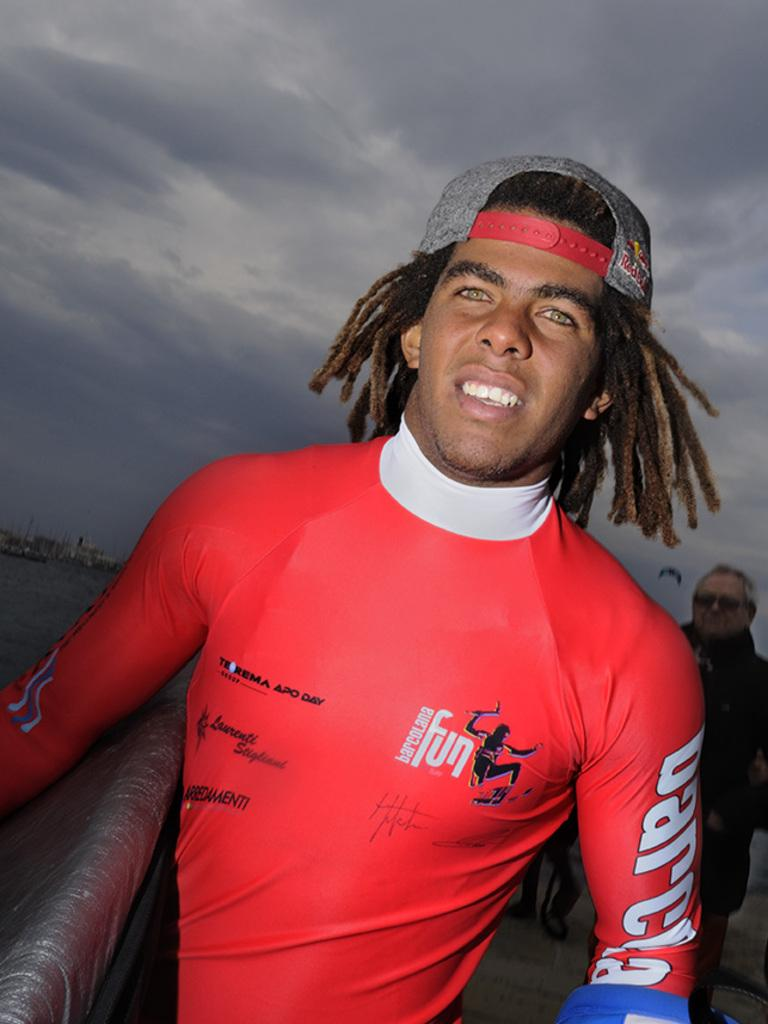<image>
Describe the image concisely. man wearing red shirt with barcolana fun on it 